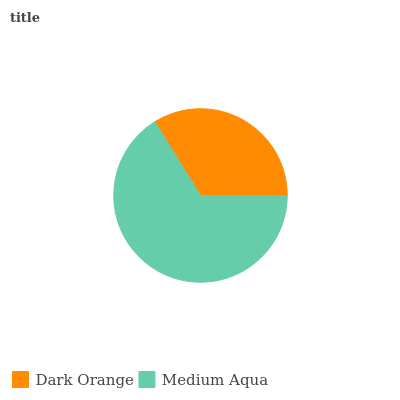Is Dark Orange the minimum?
Answer yes or no. Yes. Is Medium Aqua the maximum?
Answer yes or no. Yes. Is Medium Aqua the minimum?
Answer yes or no. No. Is Medium Aqua greater than Dark Orange?
Answer yes or no. Yes. Is Dark Orange less than Medium Aqua?
Answer yes or no. Yes. Is Dark Orange greater than Medium Aqua?
Answer yes or no. No. Is Medium Aqua less than Dark Orange?
Answer yes or no. No. Is Medium Aqua the high median?
Answer yes or no. Yes. Is Dark Orange the low median?
Answer yes or no. Yes. Is Dark Orange the high median?
Answer yes or no. No. Is Medium Aqua the low median?
Answer yes or no. No. 